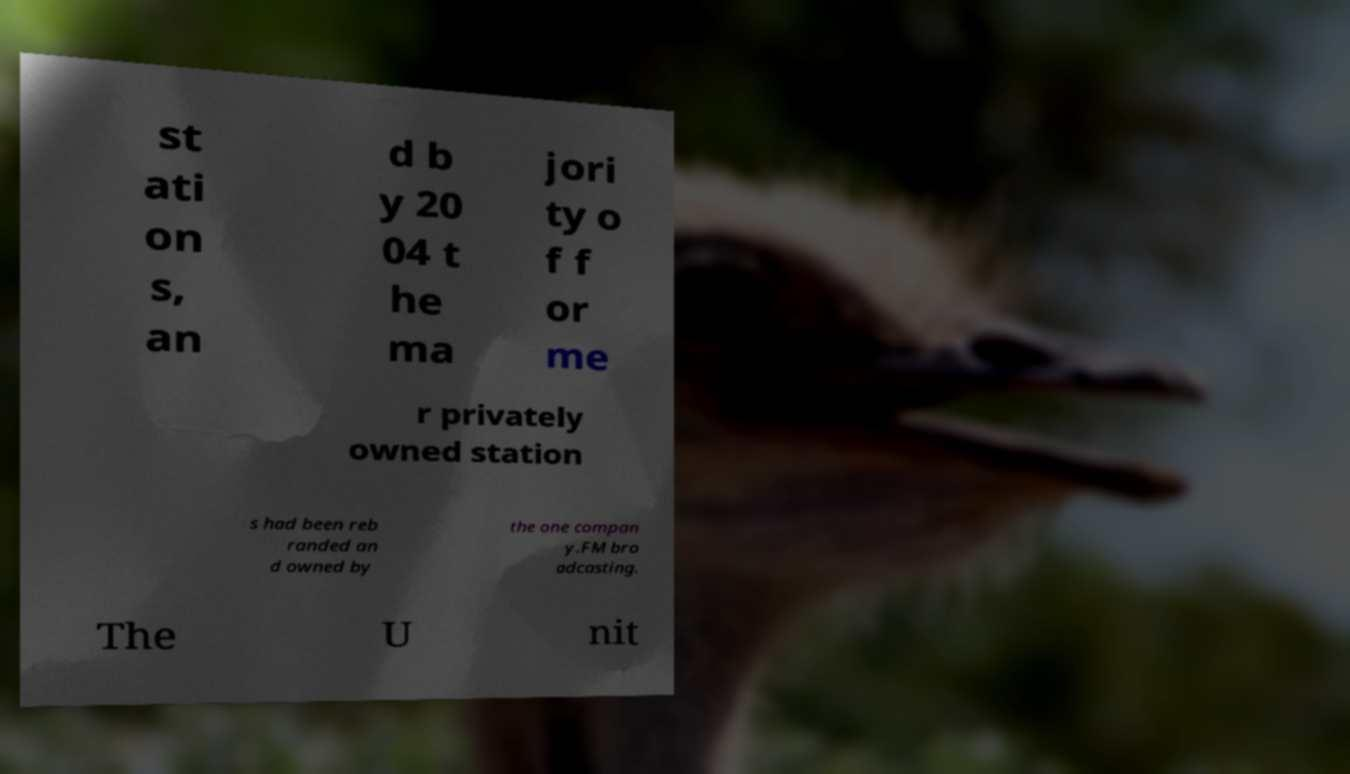For documentation purposes, I need the text within this image transcribed. Could you provide that? st ati on s, an d b y 20 04 t he ma jori ty o f f or me r privately owned station s had been reb randed an d owned by the one compan y.FM bro adcasting. The U nit 